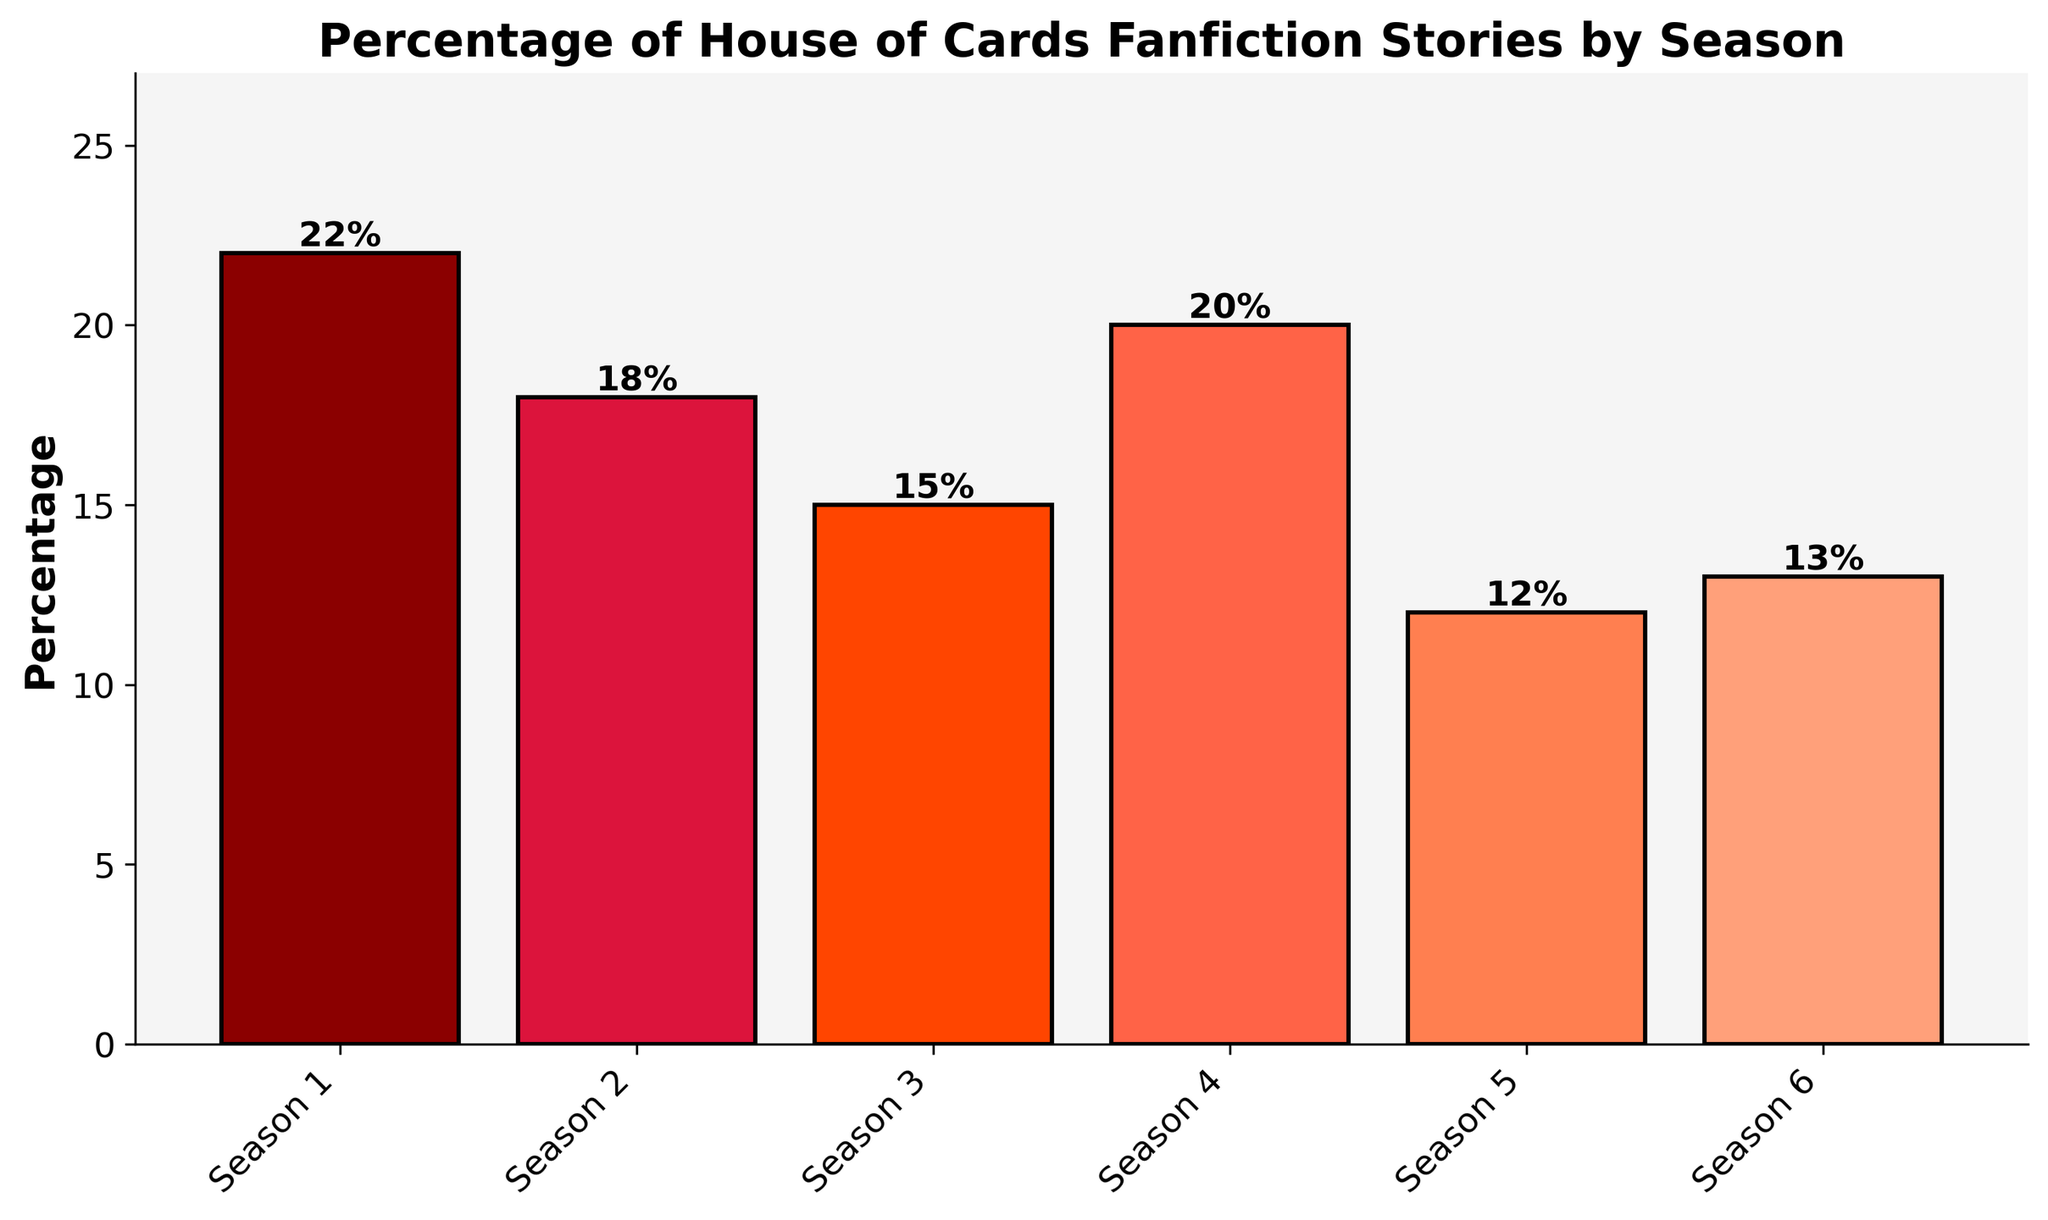What season has the highest percentage of fanfiction stories? Looking at the heights of the bars, Season 1 has the tallest bar, indicating it has the highest percentage. The label on top of the bar confirms this with 22%.
Answer: Season 1 Which season has the lowest percentage of fanfiction stories? The shortest bar represents the smallest percentage. Season 5 has the shortest bar, and the label indicates 12%.
Answer: Season 5 What is the difference in percentage between the most and least popular seasons for fanfiction? The most popular season is Season 1 with 22%, and the least popular is Season 5 with 12%. The difference is 22% - 12% = 10%.
Answer: 10% Are there any seasons with the same percentage of fanfiction stories? Comparing the heights and labels of the bars, no two seasons have the same percentage; each one is unique.
Answer: No Which two consecutive seasons combined make up the highest percentage of fanfiction stories? Considering all pairs of consecutive seasons:
- Season 1 (22%) + Season 2 (18%) = 40%
- Season 2 (18%) + Season 3 (15%) = 33%
- Season 3 (15%) + Season 4 (20%) = 35%
- Season 4 (20%) + Season 5 (12%) = 32%
- Season 5 (12%) + Season 6 (13%) = 25%
The combination of Season 1 and Season 2 has the highest percentage at 40%.
Answer: Season 1 and Season 2 What is the average percentage of fanfiction stories across all seasons? Sum the percentages of all seasons: 22 + 18 + 15 + 20 + 12 + 13 = 100. Divide by the number of seasons: 100/6 ≈ 16.67%.
Answer: 16.67% Which season, besides Season 1, has a noticeable peak in fanfiction percentage based on visual comparison? Besides Season 1, Season 4 has the next tallest bar, indicating a peak in percentage.
Answer: Season 4 Are there any seasons where the bars are colored in shades of the same color family? Observing the colors, all bars are in shades of red, ranging from dark red to light coral.
Answer: Yes What is the total percentage for Seasons 3 and 6 combined? Add the percentages of Season 3 (15%) and Season 6 (13%): 15% + 13% = 28%.
Answer: 28% What percentage of fanfiction stories is dedicated to seasons 4 and 5 combined and how does it compare to season 1? Add the percentages for Season 4 (20%) and Season 5 (12%): 20% + 12% = 32%. Season 1 has 22%. Compare: 32% - 22% = 10%. So, it's 10% more than Season 1.
Answer: 32%, 10% more 